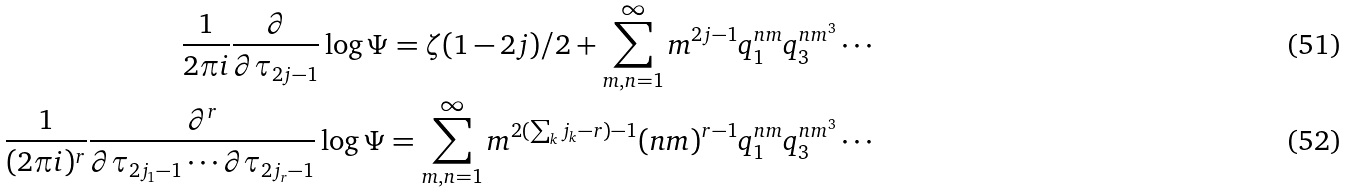<formula> <loc_0><loc_0><loc_500><loc_500>\frac { 1 } { 2 \pi i } \frac { \partial } { \partial \tau _ { 2 j - 1 } } \log \Psi = \zeta ( 1 - 2 j ) / 2 + \sum _ { m , n = 1 } ^ { \infty } m ^ { 2 j - 1 } q _ { 1 } ^ { n m } q _ { 3 } ^ { n m ^ { 3 } } \cdots \\ \frac { 1 } { ( 2 \pi i ) ^ { r } } \frac { \partial ^ { r } } { \partial \tau _ { 2 j _ { 1 } - 1 } \cdots \partial \tau _ { 2 j _ { r } - 1 } } \log \Psi = \sum _ { m , n = 1 } ^ { \infty } m ^ { 2 ( \sum _ { k } j _ { k } - r ) - 1 } ( n m ) ^ { r - 1 } q _ { 1 } ^ { n m } q _ { 3 } ^ { n m ^ { 3 } } \cdots</formula> 